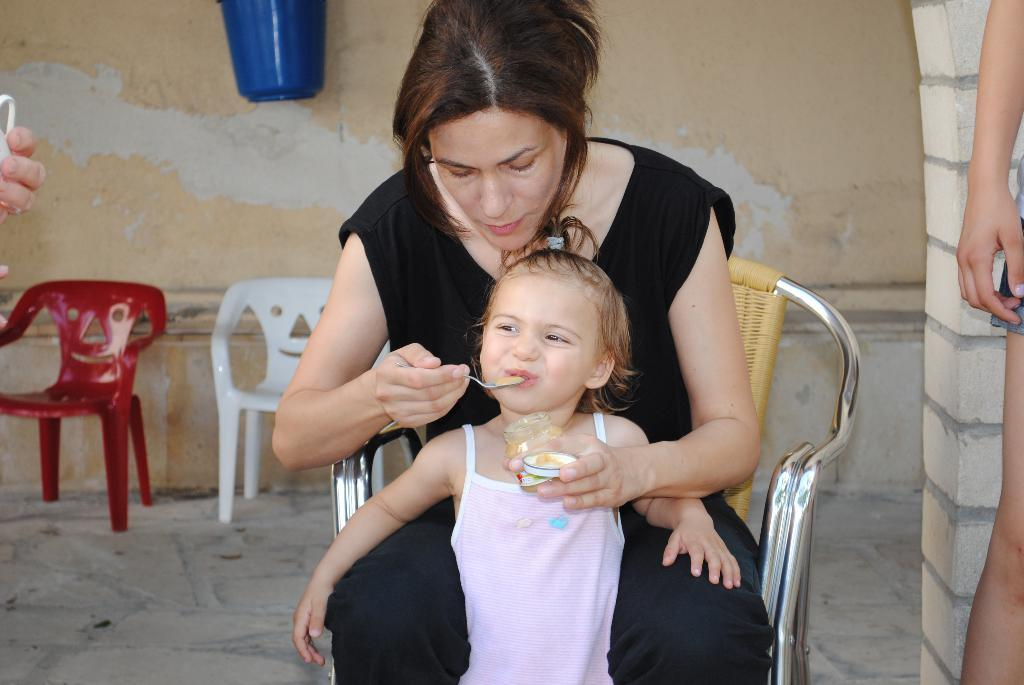Who is the main subject in the image? There is a woman in the image. What is the woman doing in the image? The woman is sitting on a chair and feeding food to a kid. What is the position of the kid in the image? The kid is standing. What can be seen in the background of the image? There is a wall, a bucket, and chairs in the background of the image. What type of cast is visible on the woman's leg in the image? There is no cast visible on the woman's leg in the image. What color is the sock on the kid's foot in the image? There is no sock visible on the kid's foot in the image. 